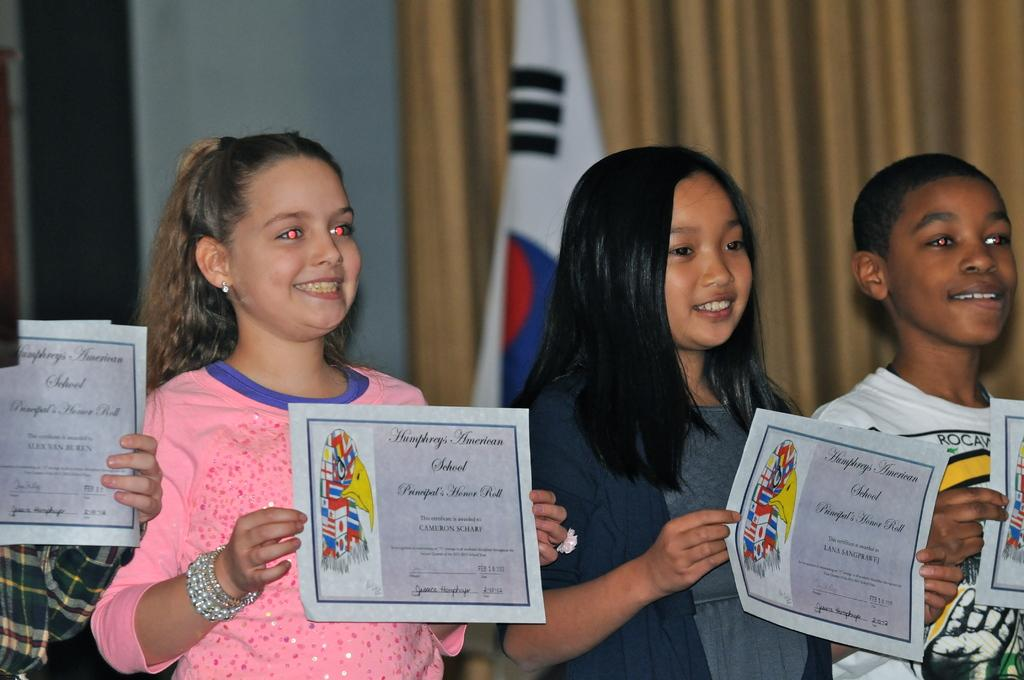What are the people in the image doing? The people in the image are standing and smiling. What are the people holding in the image? The people are holding papers in the image. What can be seen in the background of the image? There is a flag, a curtain, and a wall in the background of the image. What type of bird is flying over the people in the image? There is no bird present in the image. What is the chance of winning a prize in the image? There is no indication of a prize or a chance to win in the image. 